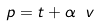Convert formula to latex. <formula><loc_0><loc_0><loc_500><loc_500>p = t + \alpha \ v</formula> 